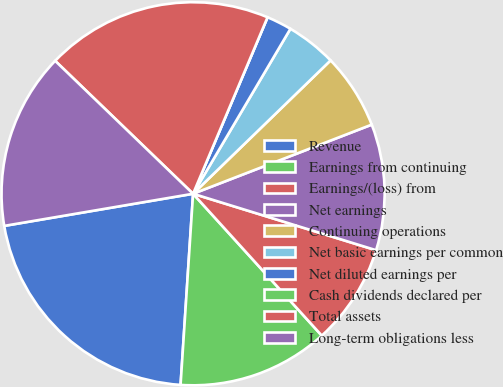Convert chart to OTSL. <chart><loc_0><loc_0><loc_500><loc_500><pie_chart><fcel>Revenue<fcel>Earnings from continuing<fcel>Earnings/(loss) from<fcel>Net earnings<fcel>Continuing operations<fcel>Net basic earnings per common<fcel>Net diluted earnings per<fcel>Cash dividends declared per<fcel>Total assets<fcel>Long-term obligations less<nl><fcel>21.28%<fcel>12.77%<fcel>8.51%<fcel>10.64%<fcel>6.38%<fcel>4.26%<fcel>2.13%<fcel>0.0%<fcel>19.15%<fcel>14.89%<nl></chart> 